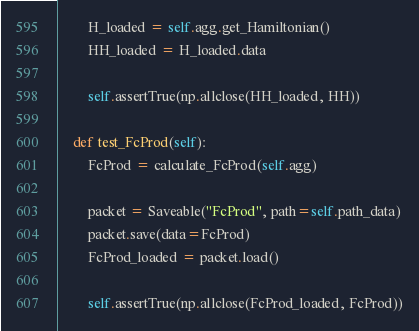Convert code to text. <code><loc_0><loc_0><loc_500><loc_500><_Python_>        H_loaded = self.agg.get_Hamiltonian()
        HH_loaded = H_loaded.data

        self.assertTrue(np.allclose(HH_loaded, HH))

    def test_FcProd(self):
        FcProd = calculate_FcProd(self.agg)

        packet = Saveable("FcProd", path=self.path_data)
        packet.save(data=FcProd)
        FcProd_loaded = packet.load()

        self.assertTrue(np.allclose(FcProd_loaded, FcProd))
</code> 